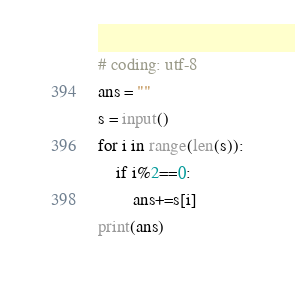<code> <loc_0><loc_0><loc_500><loc_500><_Python_># coding: utf-8
ans = ""
s = input()
for i in range(len(s)):
    if i%2==0:
        ans+=s[i]
print(ans)</code> 